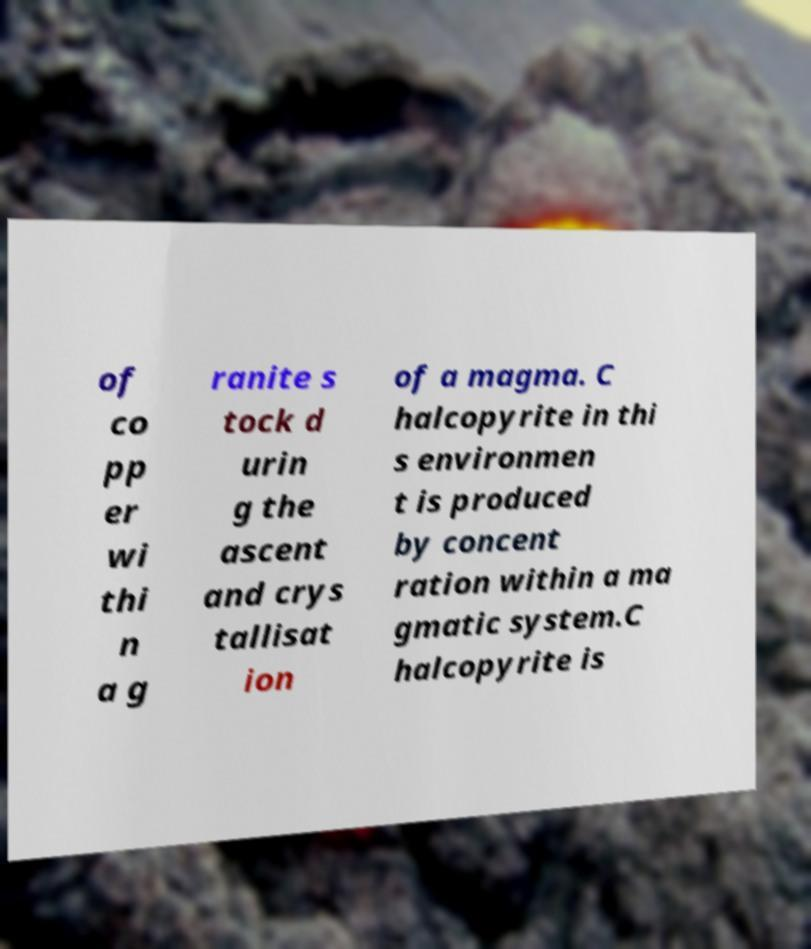There's text embedded in this image that I need extracted. Can you transcribe it verbatim? of co pp er wi thi n a g ranite s tock d urin g the ascent and crys tallisat ion of a magma. C halcopyrite in thi s environmen t is produced by concent ration within a ma gmatic system.C halcopyrite is 